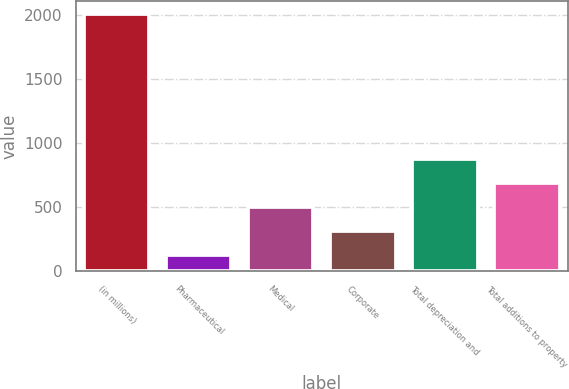Convert chart to OTSL. <chart><loc_0><loc_0><loc_500><loc_500><bar_chart><fcel>(in millions)<fcel>Pharmaceutical<fcel>Medical<fcel>Corporate<fcel>Total depreciation and<fcel>Total additions to property<nl><fcel>2013<fcel>125<fcel>502.6<fcel>313.8<fcel>880.2<fcel>691.4<nl></chart> 